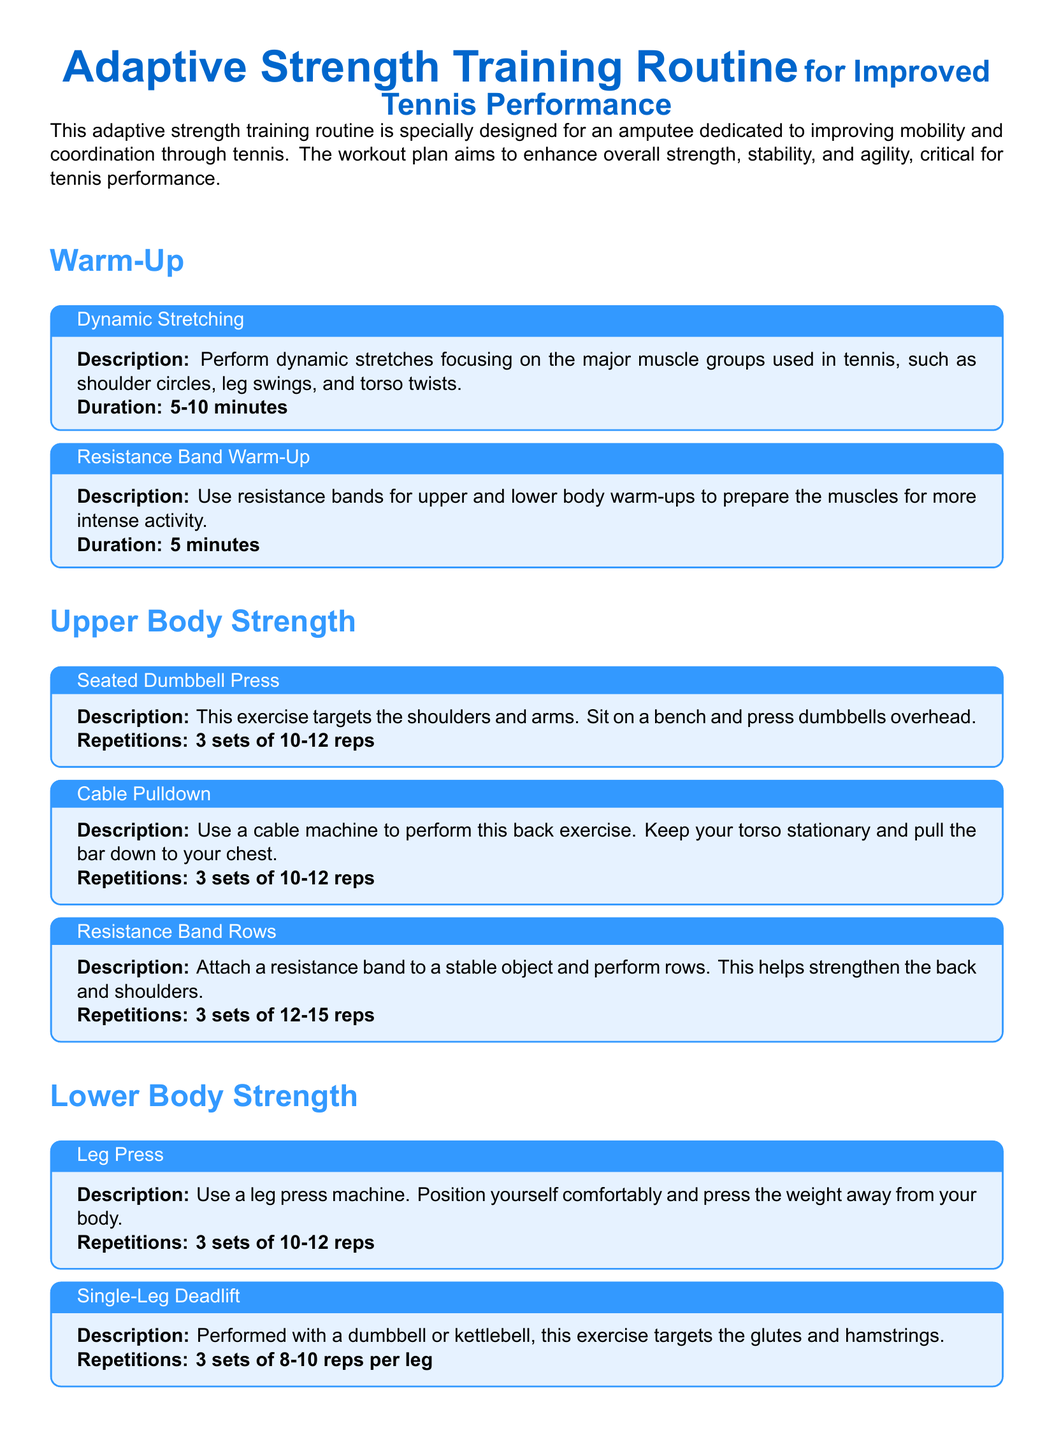What is the duration of the dynamic stretching warm-up? The duration of the dynamic stretching warm-up is specified in the document.
Answer: 5-10 minutes How many sets of the seated dumbbell press should be performed? The number of sets for the seated dumbbell press is mentioned in the workout plan.
Answer: 3 sets What type of exercise is the leg press? The leg press is categorized under lower body strength exercises in the document.
Answer: Lower body strength How long should planks be held during core strength training? The duration for holding planks is listed under the core strength section in the document.
Answer: 30-60 seconds What is the focus of the cool down session? The focus of the cool down session includes activities listed in the document, particularly stretching and breathing exercises.
Answer: Stretching and relaxation What equipment is used for balance board squats? The equipment specified for balance board squats in the document is a balance board.
Answer: Balance board Which muscle groups are targeted by the resistance band rows? The document details which muscle groups are engaged by the resistance band rows.
Answer: Back and shoulders What should be done for the resistance band warm-up? The document specifies the purpose and method of the resistance band warm-up.
Answer: Upper and lower body warm-ups 